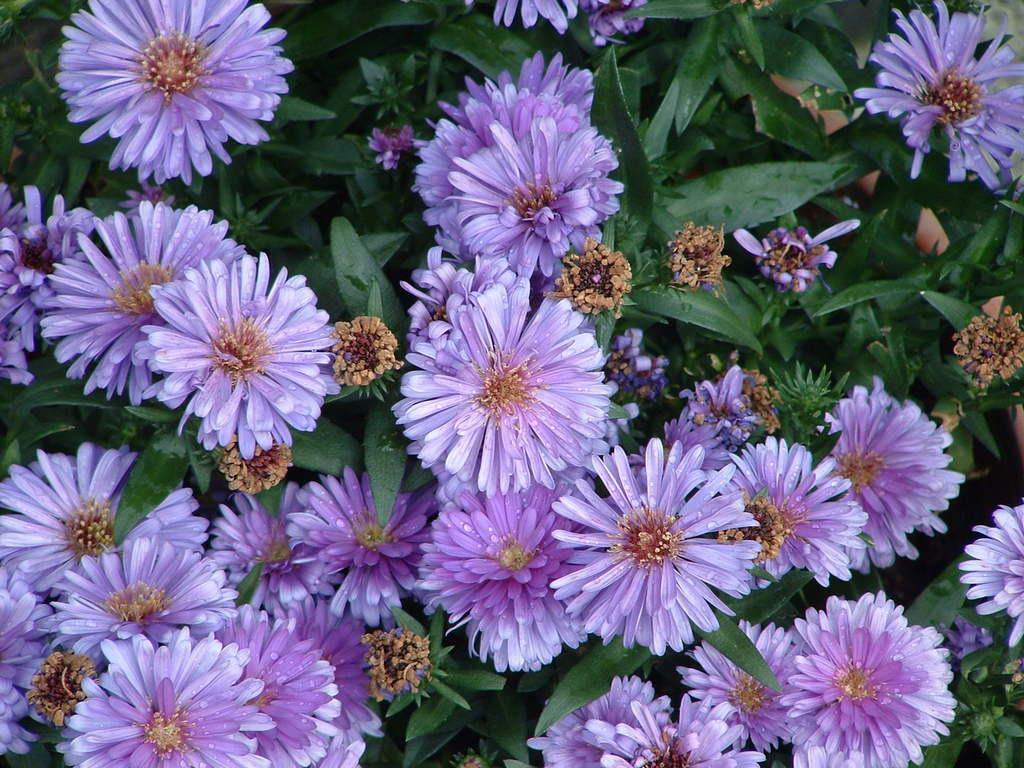What is the main subject of the image? The main subject of the image is a group of flowers. What else can be seen in the image besides the flowers? There are leaves in the image. What type of wool can be seen in the image? There is no wool present in the image. What type of jar is visible in the image? There is no jar present in the image. How many tomatoes can be seen in the image? There are no tomatoes present in the image. 